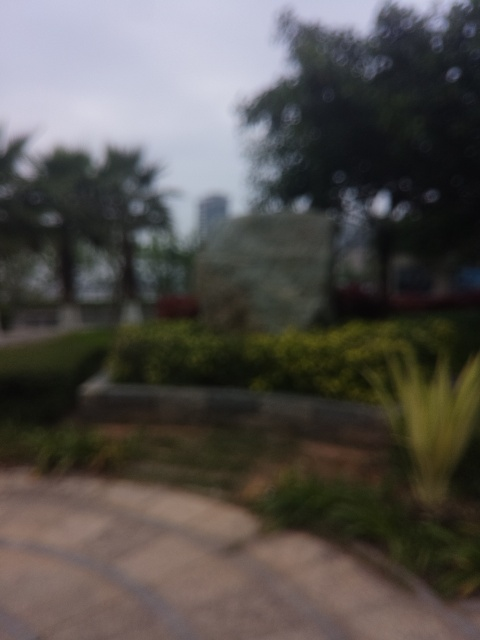How does the weather seem to be in the location of this stone carving? The image suggests overcast or hazy weather conditions, as the lighting appears soft and diffuse, with no harsh shadows or bright sunlight visible. 